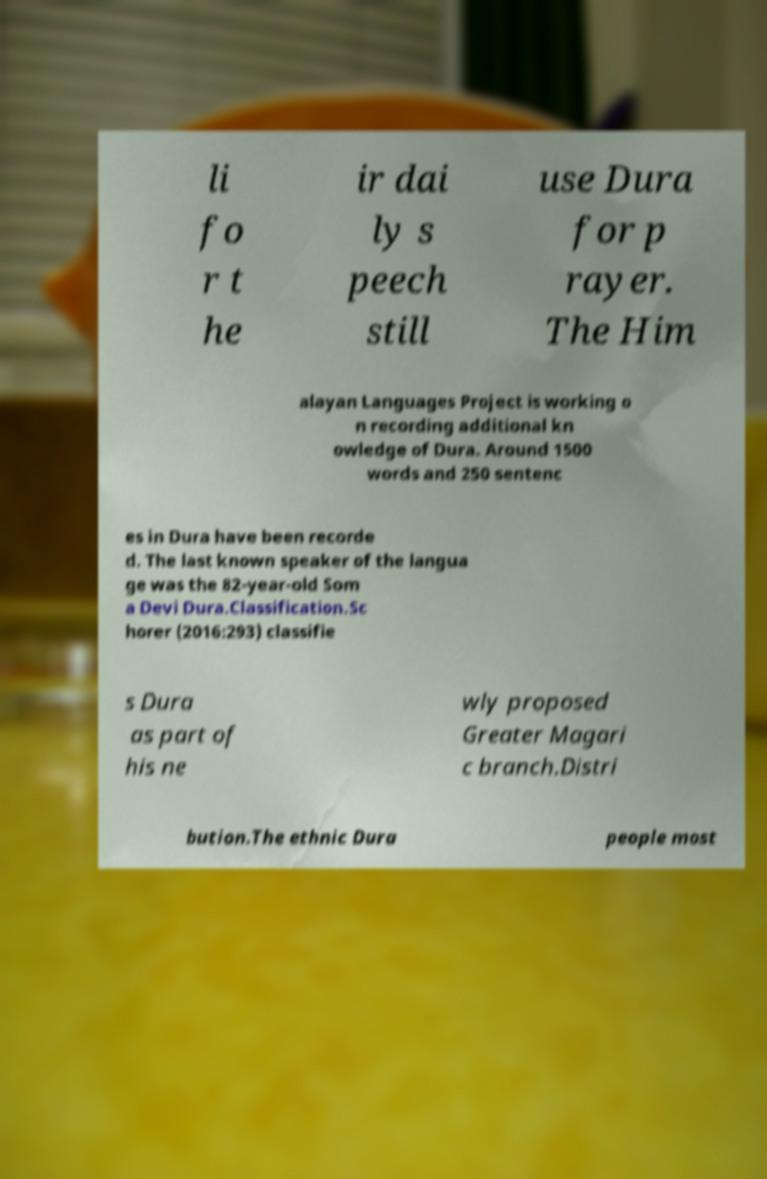What messages or text are displayed in this image? I need them in a readable, typed format. li fo r t he ir dai ly s peech still use Dura for p rayer. The Him alayan Languages Project is working o n recording additional kn owledge of Dura. Around 1500 words and 250 sentenc es in Dura have been recorde d. The last known speaker of the langua ge was the 82-year-old Som a Devi Dura.Classification.Sc horer (2016:293) classifie s Dura as part of his ne wly proposed Greater Magari c branch.Distri bution.The ethnic Dura people most 